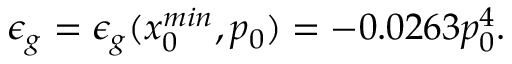<formula> <loc_0><loc_0><loc_500><loc_500>\epsilon _ { g } = \epsilon _ { g } ( x _ { 0 } ^ { \min } , p _ { 0 } ) = - 0 . 0 2 6 3 p _ { 0 } ^ { 4 } .</formula> 